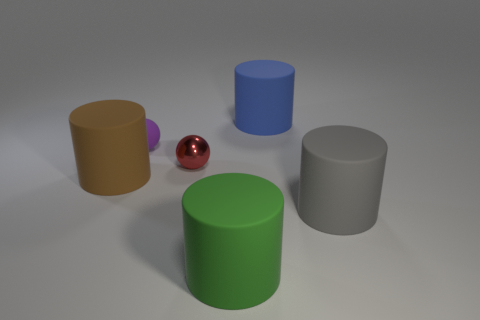Add 3 small red rubber spheres. How many objects exist? 9 Subtract all cylinders. How many objects are left? 2 Add 4 small balls. How many small balls exist? 6 Subtract 0 blue cubes. How many objects are left? 6 Subtract all tiny green metallic objects. Subtract all large gray rubber cylinders. How many objects are left? 5 Add 2 large gray things. How many large gray things are left? 3 